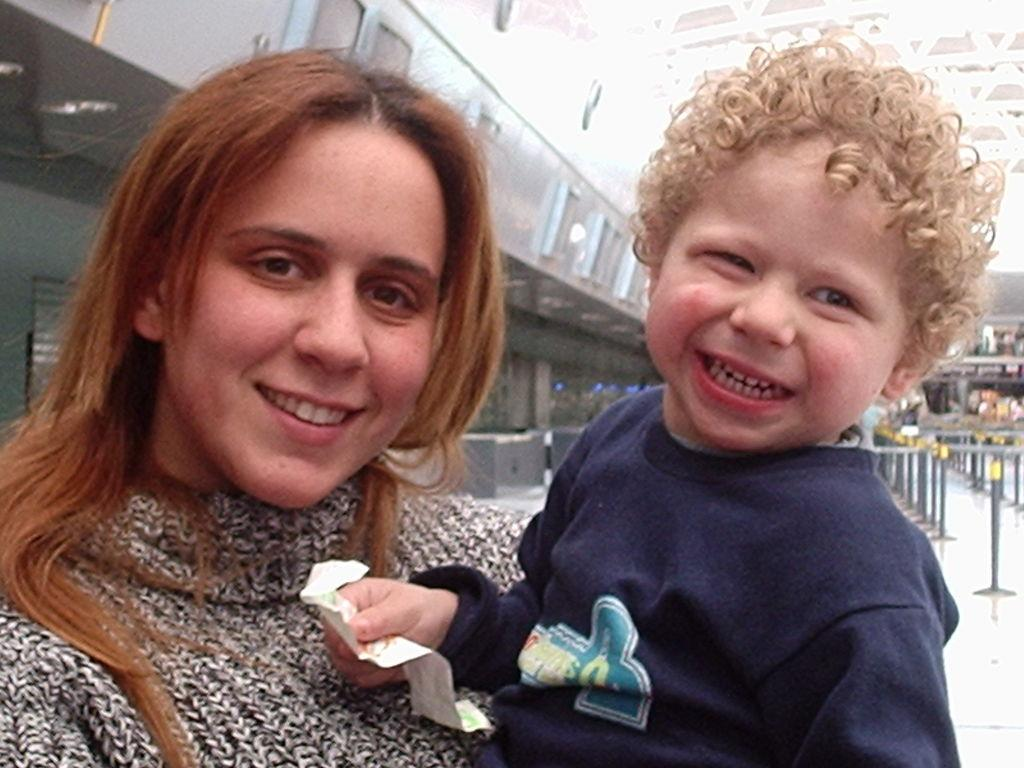Who is present in the image? There is a woman and a kid in the image. What is the kid holding? The kid is holding a paper. What can be seen in the background of the image? There is a building in the background of the image. What type of attack is being carried out by the woman in the image? There is no indication of an attack in the image; the woman and the kid are simply present. 